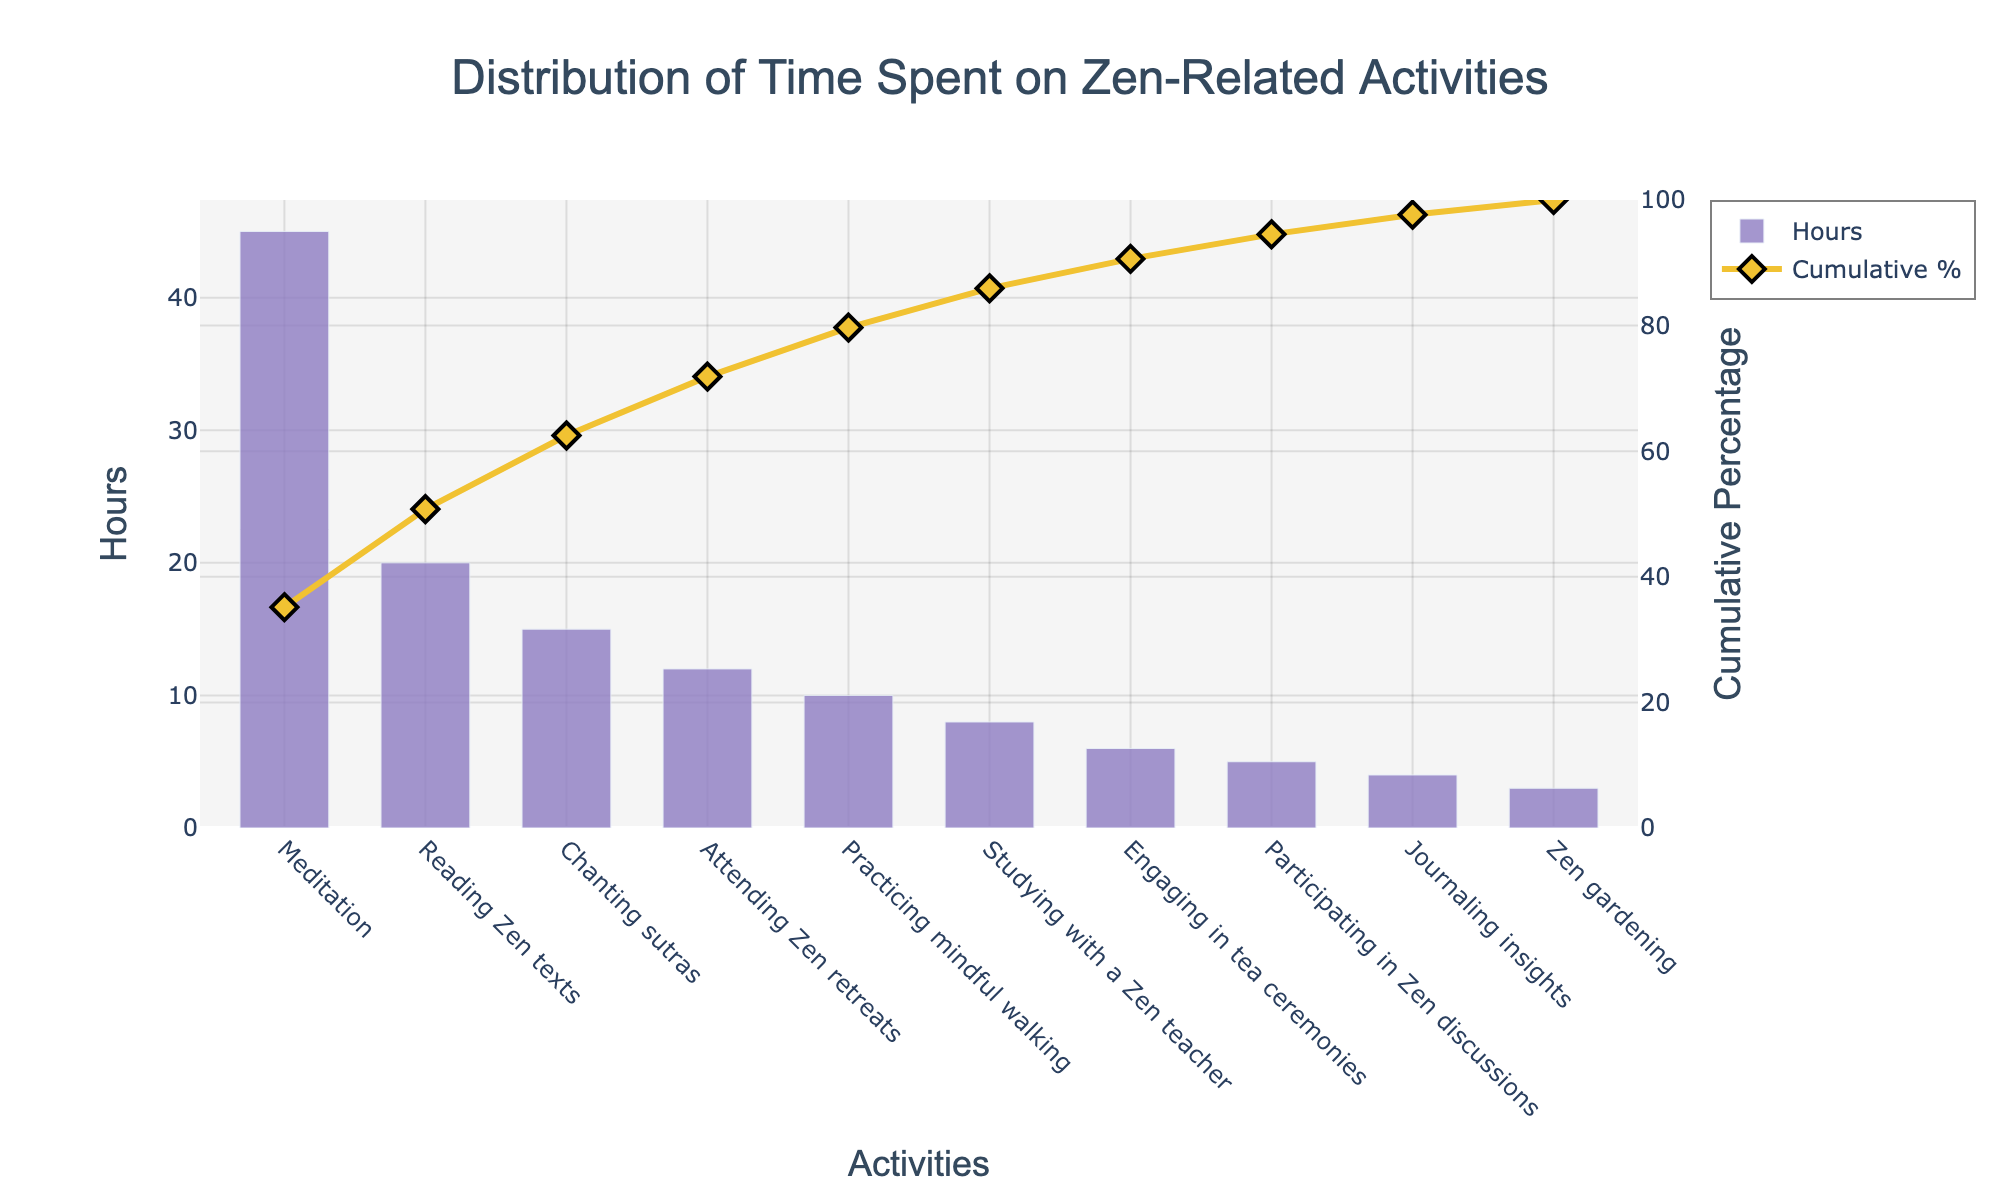What's the primary activity in the visualization? The primary activity refers to the one with the highest number of hours. By looking at the highest bar, we can see that it's labeled "Meditation," with 45 hours.
Answer: Meditation What's the cumulative percentage after the second activity? Adding the first two activities, Meditation (45 hours) and Reading Zen texts (20 hours), gives a total of 65 hours. The cumulative percentage for these two is shown as 65/128*100 = 50.78%.
Answer: 50.78% How much time is spent on activities listed after "Practicing mindful walking"? The activities after "Practicing mindful walking" are Studying with a Zen teacher (8 hours), Engaging in tea ceremonies (6 hours), Participating in Zen discussions (5 hours), Journaling insights (4 hours), and Zen gardening (3 hours). Summing these gives 8 + 6 + 5 + 4 + 3 = 26 hours.
Answer: 26 hours Which activity is associated with approximately 80% cumulative time? By analyzing the cumulative percentage line, the activities up to around 80% include Meditation (45 hours), Reading Zen texts (20 hours), Chanting sutras (15 hours), Attending Zen retreats (12 hours), and Practicing mindful walking (10 hours). Summing these gives 102 hours, and 102/128*100 ≈ 79.69%.  Therefore, Practicing mindful walking contributes to approximately 80% cumulative time.
Answer: Practicing mindful walking How many hours are dedicated to activities contributing to at least 95% of the total time? To find activities contributing to at least 95%, we need to determine which activities sum up to approximately 95% of total hours (122 hours). By reviewing the cumulative percentage and summing the hours of activities until they reach approximately 95%: Meditation (45 hours), Reading Zen texts (20 hours), Chanting sutras (15 hours), Attending Zen retreats (12 hours), Practicing mindful walking (10 hours), Studying with a Zen teacher (8 hours), Engaging in tea ceremonies (6 hours), and Participating in Zen discussions (5 hours) gives 121 hours, which is approximately 94.53%. So, 8 activities.
Answer: 8 activities What are the colors used for the bars and the cumulative percentage line? The bars are colored in a purple shade, while the cumulative percentage line is a yellow-golden shade with diamond markers.
Answer: Purple and Yellow-Golden Which two activities combined contribute to the smallest share of the total time? The two activities with the smallest hours are Participating in Zen discussions (5 hours) and Zen gardening (3 hours). Combined, they make 8 hours.
Answer: Participating in Zen discussions and Zen gardening What does the secondary y-axis represent in the Pareto chart? The secondary y-axis represents the cumulative percentage of time spent on the activities.
Answer: Cumulative percentage 